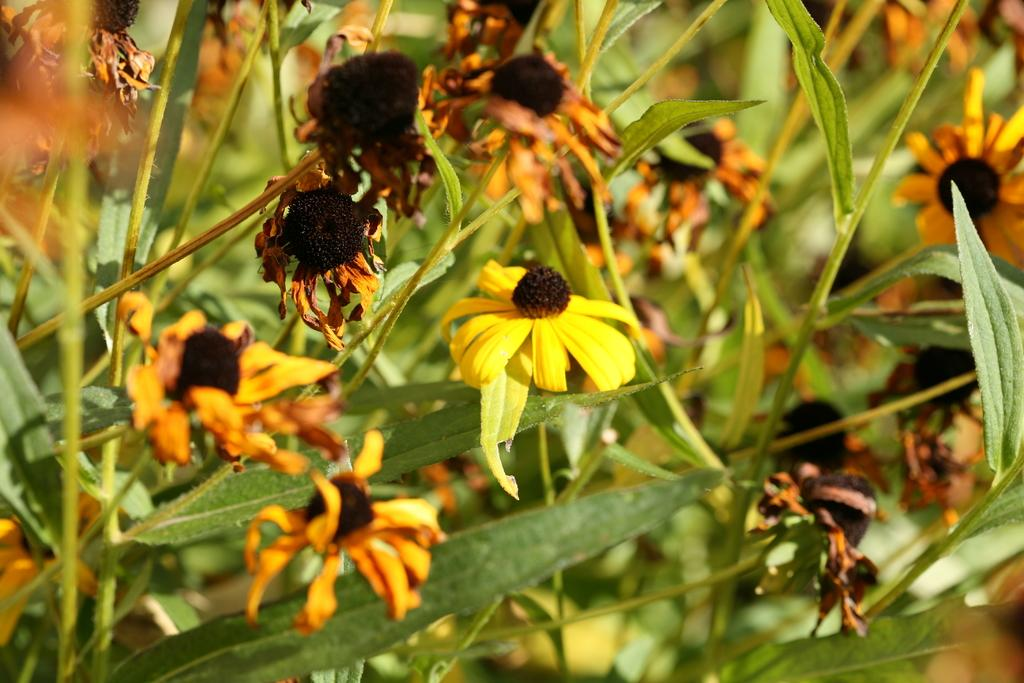What colors are the flowers in the image? The flowers in the image are yellow and black. What color are the leaves in the image? The leaves in the image are green. What type of brick can be seen in the image? There is no brick present in the image; it features yellow and black flowers and green leaves. How many quinces are visible in the image? There are no quinces present in the image; it only features flowers and leaves. 